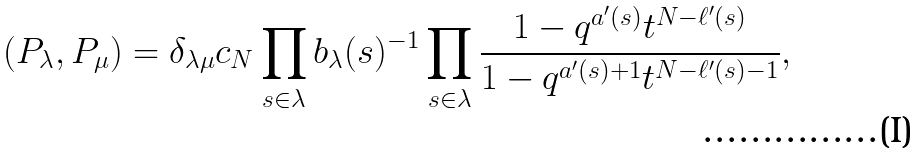Convert formula to latex. <formula><loc_0><loc_0><loc_500><loc_500>( P _ { \lambda } , P _ { \mu } ) = \delta _ { \lambda \mu } c _ { N } \prod _ { s \in \lambda } b _ { \lambda } ( s ) ^ { - 1 } \prod _ { s \in \lambda } \frac { 1 - q ^ { a ^ { \prime } ( s ) } t ^ { N - \ell ^ { \prime } ( s ) } } { 1 - q ^ { a ^ { \prime } ( s ) + 1 } t ^ { N - \ell ^ { \prime } ( s ) - 1 } } ,</formula> 